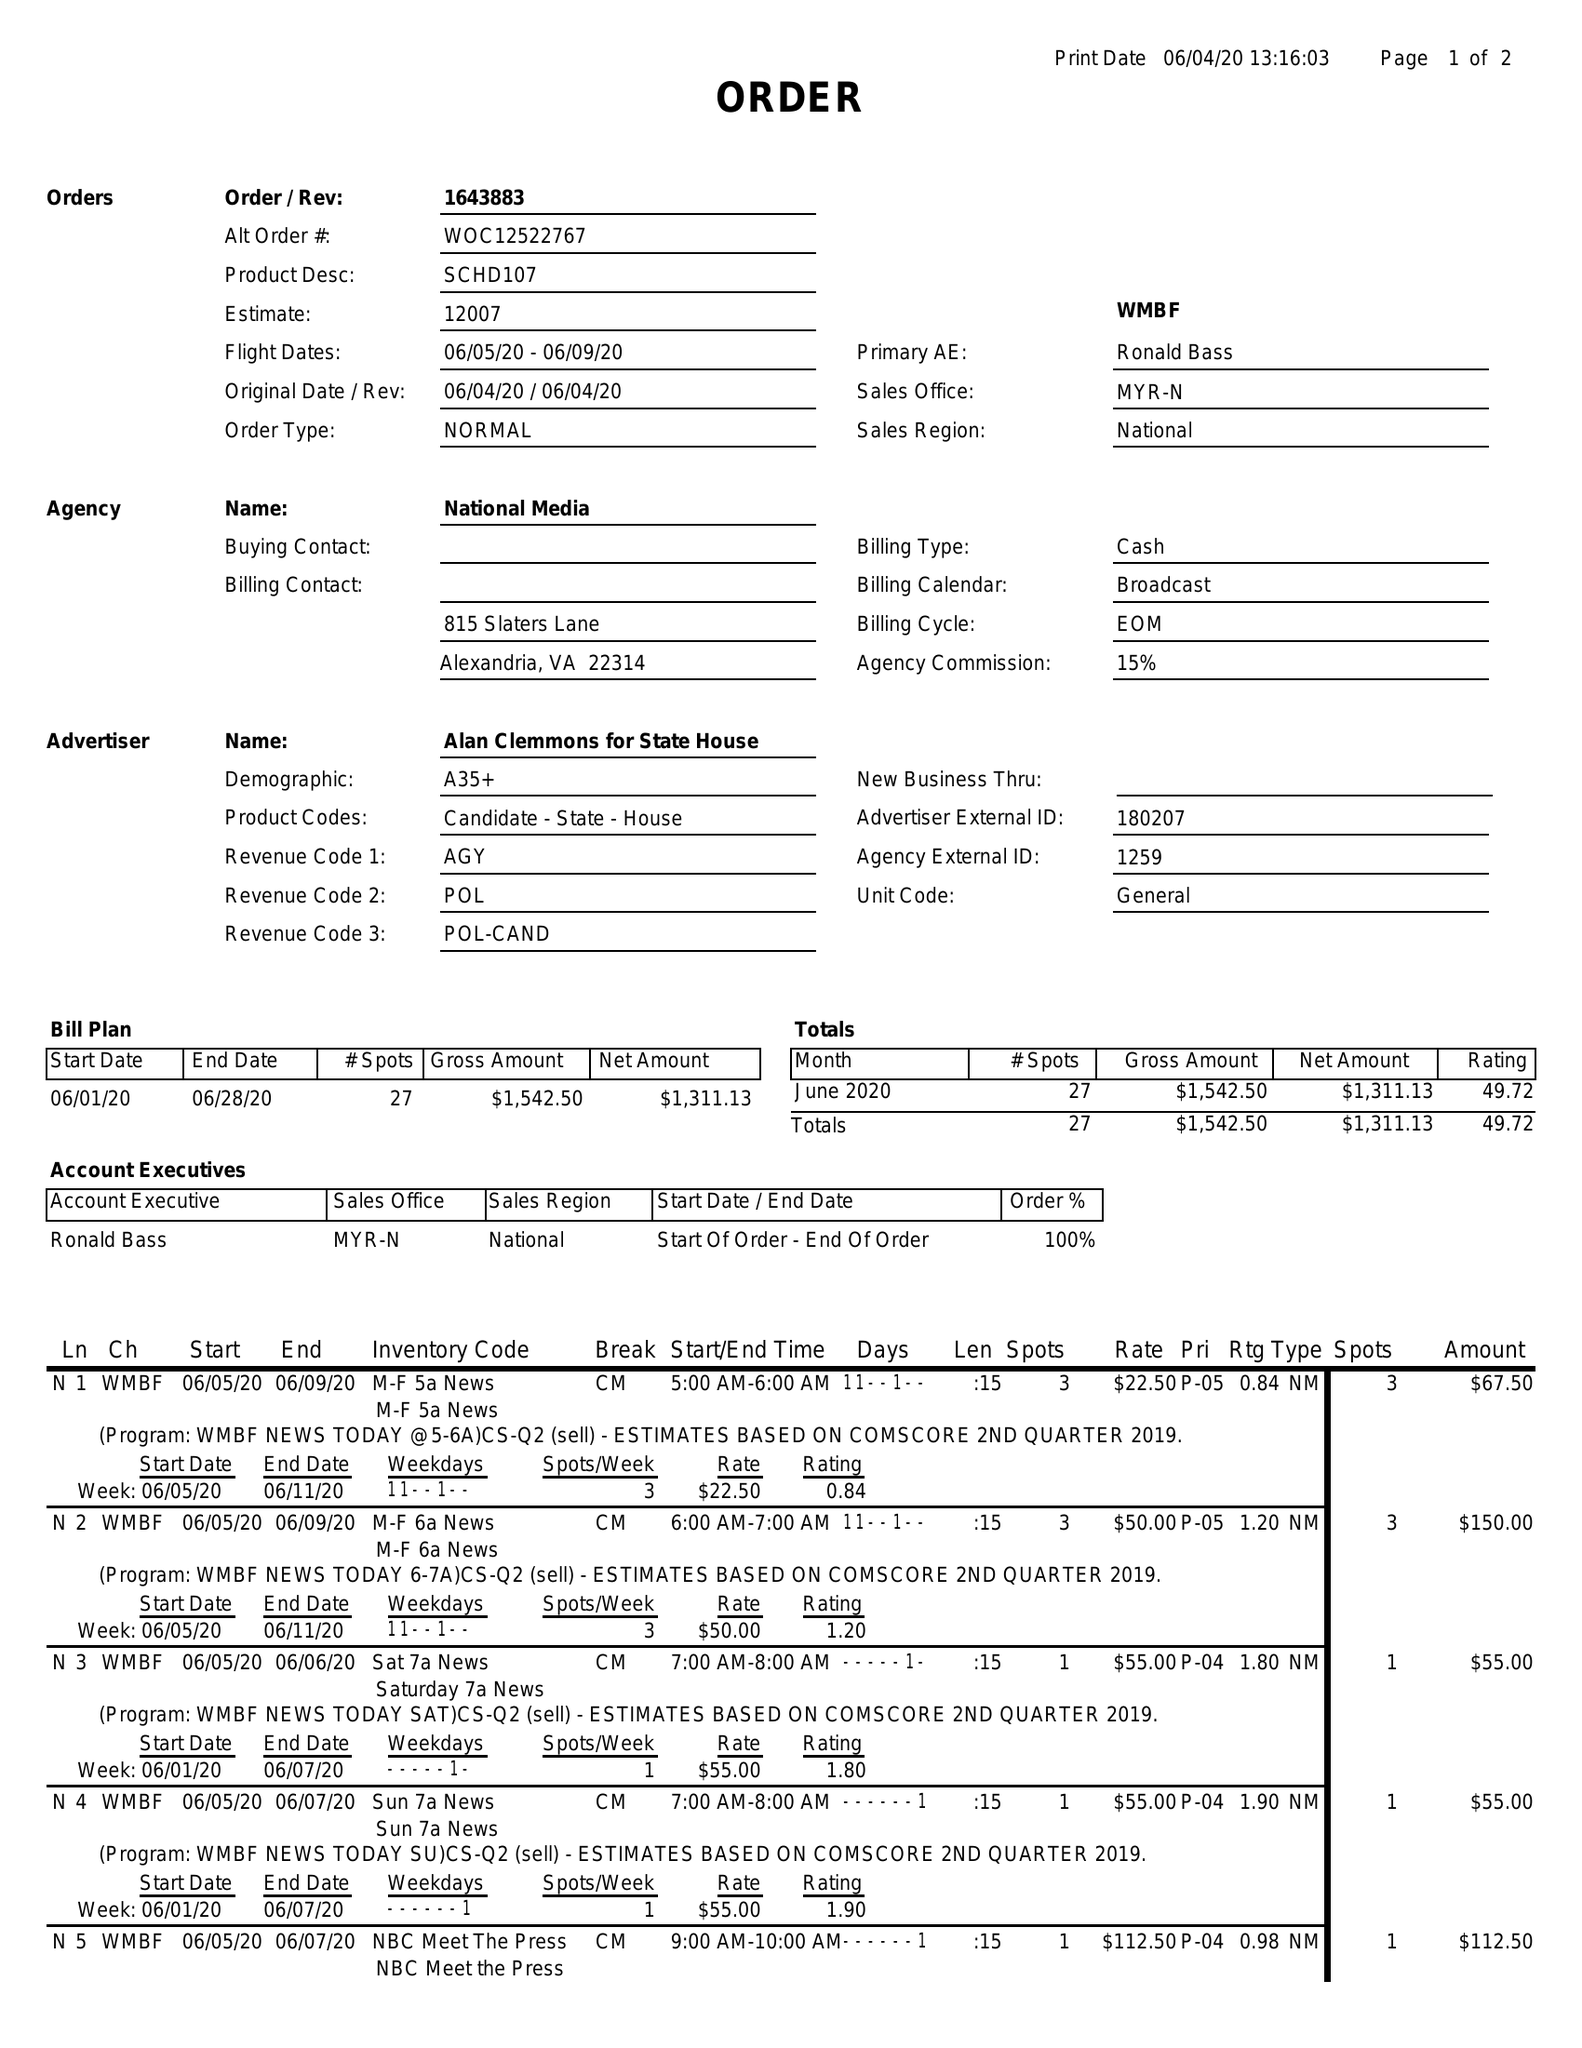What is the value for the flight_to?
Answer the question using a single word or phrase. 06/09/20 